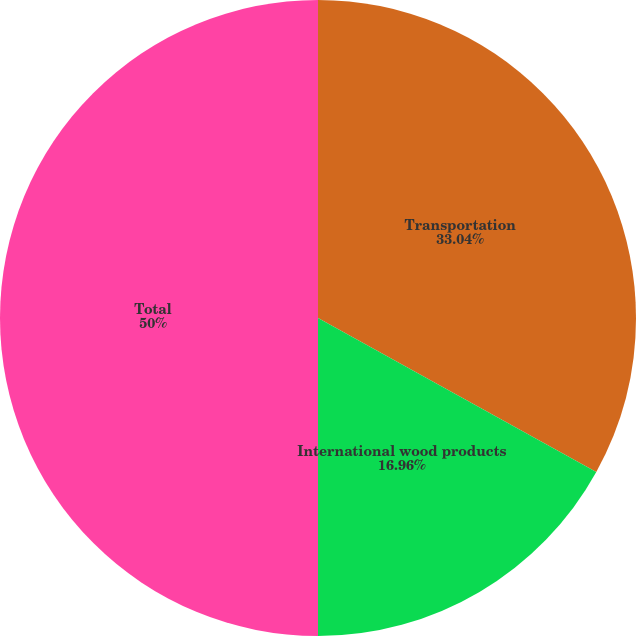<chart> <loc_0><loc_0><loc_500><loc_500><pie_chart><fcel>Transportation<fcel>International wood products<fcel>Total<nl><fcel>33.04%<fcel>16.96%<fcel>50.0%<nl></chart> 